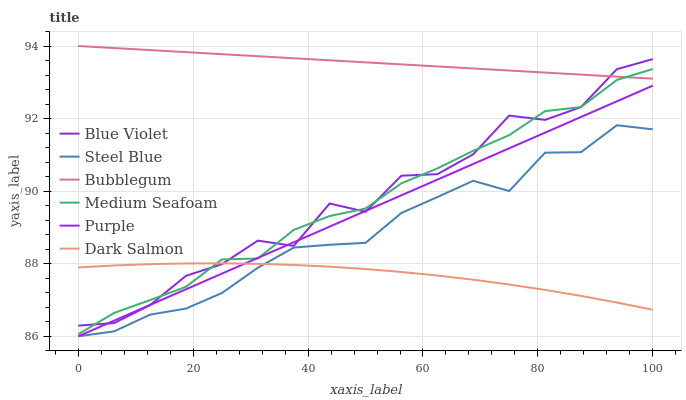Does Dark Salmon have the minimum area under the curve?
Answer yes or no. Yes. Does Bubblegum have the maximum area under the curve?
Answer yes or no. Yes. Does Bubblegum have the minimum area under the curve?
Answer yes or no. No. Does Dark Salmon have the maximum area under the curve?
Answer yes or no. No. Is Bubblegum the smoothest?
Answer yes or no. Yes. Is Blue Violet the roughest?
Answer yes or no. Yes. Is Dark Salmon the smoothest?
Answer yes or no. No. Is Dark Salmon the roughest?
Answer yes or no. No. Does Purple have the lowest value?
Answer yes or no. Yes. Does Dark Salmon have the lowest value?
Answer yes or no. No. Does Bubblegum have the highest value?
Answer yes or no. Yes. Does Dark Salmon have the highest value?
Answer yes or no. No. Is Dark Salmon less than Bubblegum?
Answer yes or no. Yes. Is Medium Seafoam greater than Steel Blue?
Answer yes or no. Yes. Does Purple intersect Medium Seafoam?
Answer yes or no. Yes. Is Purple less than Medium Seafoam?
Answer yes or no. No. Is Purple greater than Medium Seafoam?
Answer yes or no. No. Does Dark Salmon intersect Bubblegum?
Answer yes or no. No. 